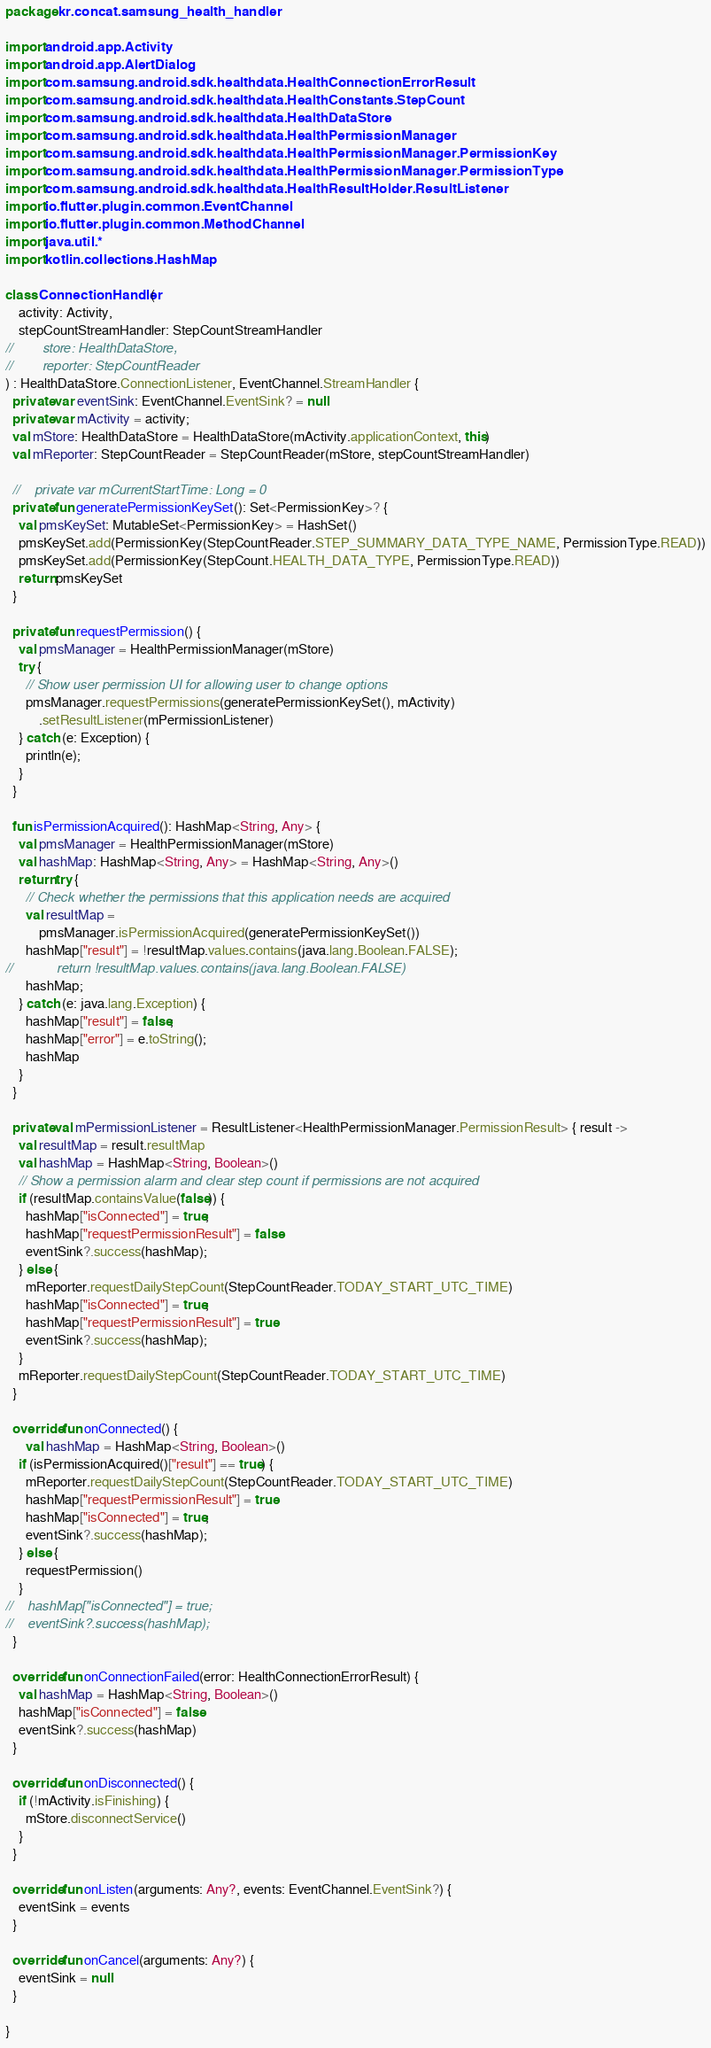Convert code to text. <code><loc_0><loc_0><loc_500><loc_500><_Kotlin_>package kr.concat.samsung_health_handler

import android.app.Activity
import android.app.AlertDialog
import com.samsung.android.sdk.healthdata.HealthConnectionErrorResult
import com.samsung.android.sdk.healthdata.HealthConstants.StepCount
import com.samsung.android.sdk.healthdata.HealthDataStore
import com.samsung.android.sdk.healthdata.HealthPermissionManager
import com.samsung.android.sdk.healthdata.HealthPermissionManager.PermissionKey
import com.samsung.android.sdk.healthdata.HealthPermissionManager.PermissionType
import com.samsung.android.sdk.healthdata.HealthResultHolder.ResultListener
import io.flutter.plugin.common.EventChannel
import io.flutter.plugin.common.MethodChannel
import java.util.*
import kotlin.collections.HashMap

class ConnectionHandler(
    activity: Activity,
    stepCountStreamHandler: StepCountStreamHandler
//        store: HealthDataStore,
//        reporter: StepCountReader
) : HealthDataStore.ConnectionListener, EventChannel.StreamHandler {
  private var eventSink: EventChannel.EventSink? = null
  private var mActivity = activity;
  val mStore: HealthDataStore = HealthDataStore(mActivity.applicationContext, this)
  val mReporter: StepCountReader = StepCountReader(mStore, stepCountStreamHandler)

  //    private var mCurrentStartTime: Long = 0
  private fun generatePermissionKeySet(): Set<PermissionKey>? {
    val pmsKeySet: MutableSet<PermissionKey> = HashSet()
    pmsKeySet.add(PermissionKey(StepCountReader.STEP_SUMMARY_DATA_TYPE_NAME, PermissionType.READ))
    pmsKeySet.add(PermissionKey(StepCount.HEALTH_DATA_TYPE, PermissionType.READ))
    return pmsKeySet
  }

  private fun requestPermission() {
    val pmsManager = HealthPermissionManager(mStore)
    try {
      // Show user permission UI for allowing user to change options
      pmsManager.requestPermissions(generatePermissionKeySet(), mActivity)
          .setResultListener(mPermissionListener)
    } catch (e: Exception) {
      println(e);
    }
  }

  fun isPermissionAcquired(): HashMap<String, Any> {
    val pmsManager = HealthPermissionManager(mStore)
    val hashMap: HashMap<String, Any> = HashMap<String, Any>()
    return try {
      // Check whether the permissions that this application needs are acquired
      val resultMap =
          pmsManager.isPermissionAcquired(generatePermissionKeySet())
      hashMap["result"] = !resultMap.values.contains(java.lang.Boolean.FALSE);
//            return !resultMap.values.contains(java.lang.Boolean.FALSE)
      hashMap;
    } catch (e: java.lang.Exception) {
      hashMap["result"] = false;
      hashMap["error"] = e.toString();
      hashMap
    }
  }

  private val mPermissionListener = ResultListener<HealthPermissionManager.PermissionResult> { result ->
    val resultMap = result.resultMap
    val hashMap = HashMap<String, Boolean>()
    // Show a permission alarm and clear step count if permissions are not acquired
    if (resultMap.containsValue(false)) {
      hashMap["isConnected"] = true;
      hashMap["requestPermissionResult"] = false
      eventSink?.success(hashMap);
    } else {
      mReporter.requestDailyStepCount(StepCountReader.TODAY_START_UTC_TIME)
      hashMap["isConnected"] = true;
      hashMap["requestPermissionResult"] = true
      eventSink?.success(hashMap);
    }
    mReporter.requestDailyStepCount(StepCountReader.TODAY_START_UTC_TIME)
  }

  override fun onConnected() {
      val hashMap = HashMap<String, Boolean>()
    if (isPermissionAcquired()["result"] == true) {
      mReporter.requestDailyStepCount(StepCountReader.TODAY_START_UTC_TIME)
      hashMap["requestPermissionResult"] = true
      hashMap["isConnected"] = true;
      eventSink?.success(hashMap);
    } else {
      requestPermission()
    }
//    hashMap["isConnected"] = true;
//    eventSink?.success(hashMap);
  }

  override fun onConnectionFailed(error: HealthConnectionErrorResult) {
    val hashMap = HashMap<String, Boolean>()
    hashMap["isConnected"] = false
    eventSink?.success(hashMap)
  }

  override fun onDisconnected() {
    if (!mActivity.isFinishing) {
      mStore.disconnectService()
    }
  }

  override fun onListen(arguments: Any?, events: EventChannel.EventSink?) {
    eventSink = events
  }

  override fun onCancel(arguments: Any?) {
    eventSink = null
  }

}</code> 